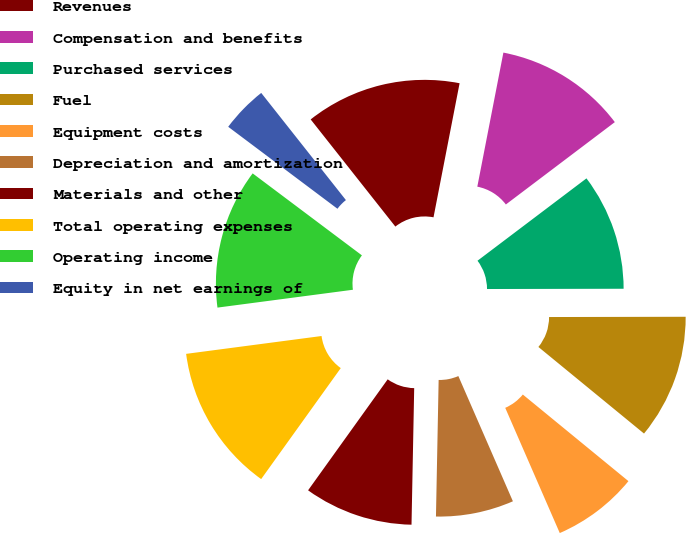Convert chart. <chart><loc_0><loc_0><loc_500><loc_500><pie_chart><fcel>Revenues<fcel>Compensation and benefits<fcel>Purchased services<fcel>Fuel<fcel>Equipment costs<fcel>Depreciation and amortization<fcel>Materials and other<fcel>Total operating expenses<fcel>Operating income<fcel>Equity in net earnings of<nl><fcel>13.7%<fcel>11.64%<fcel>10.27%<fcel>10.96%<fcel>7.53%<fcel>6.85%<fcel>9.59%<fcel>13.01%<fcel>12.33%<fcel>4.11%<nl></chart> 